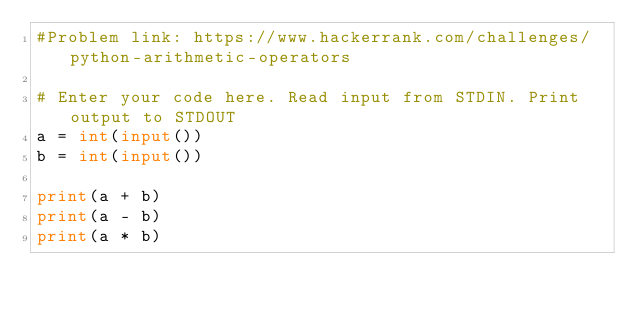<code> <loc_0><loc_0><loc_500><loc_500><_Python_>#Problem link: https://www.hackerrank.com/challenges/python-arithmetic-operators

# Enter your code here. Read input from STDIN. Print output to STDOUT
a = int(input())
b = int(input())

print(a + b)
print(a - b)
print(a * b)</code> 